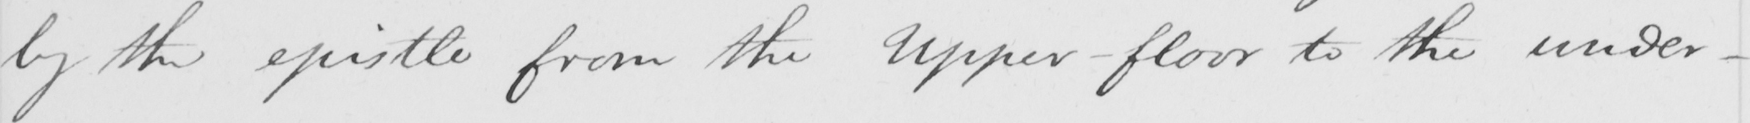What text is written in this handwritten line? by the epistle from the Upper-floor to the under  _ 